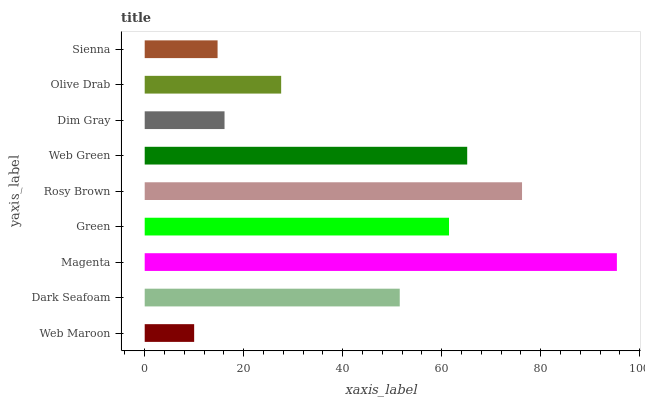Is Web Maroon the minimum?
Answer yes or no. Yes. Is Magenta the maximum?
Answer yes or no. Yes. Is Dark Seafoam the minimum?
Answer yes or no. No. Is Dark Seafoam the maximum?
Answer yes or no. No. Is Dark Seafoam greater than Web Maroon?
Answer yes or no. Yes. Is Web Maroon less than Dark Seafoam?
Answer yes or no. Yes. Is Web Maroon greater than Dark Seafoam?
Answer yes or no. No. Is Dark Seafoam less than Web Maroon?
Answer yes or no. No. Is Dark Seafoam the high median?
Answer yes or no. Yes. Is Dark Seafoam the low median?
Answer yes or no. Yes. Is Sienna the high median?
Answer yes or no. No. Is Sienna the low median?
Answer yes or no. No. 